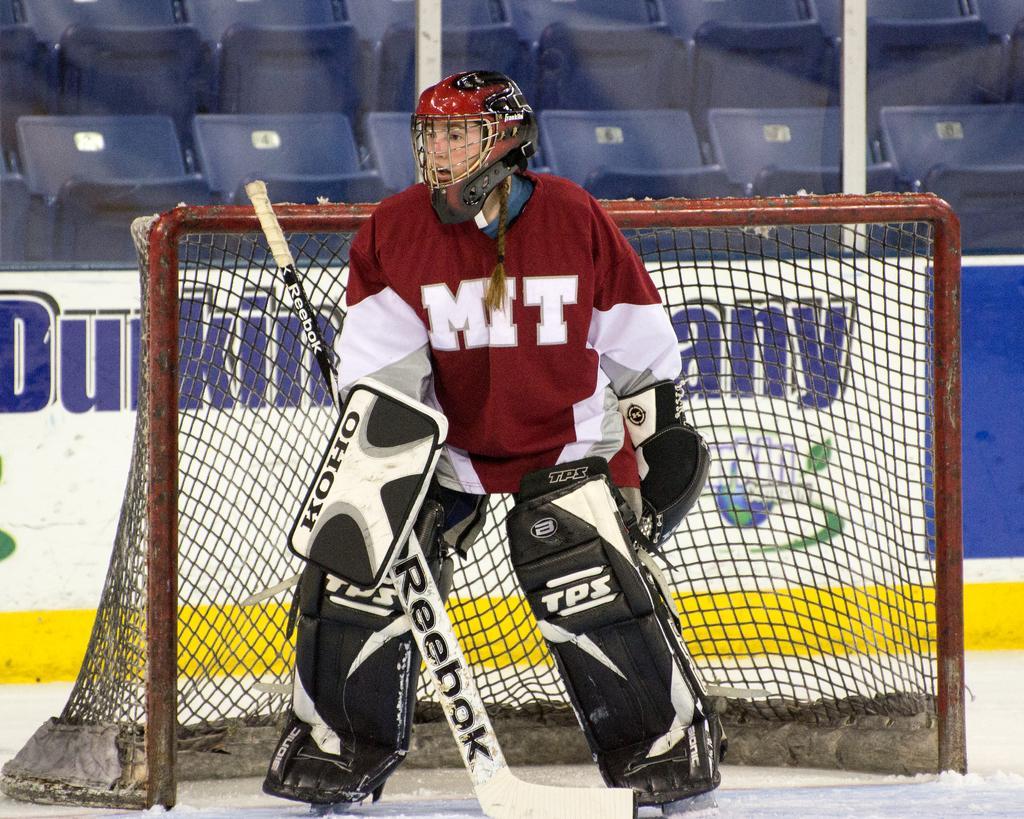Please provide a concise description of this image. In this image we can see a man wearing the helmet and also holding an object. We can also see the fence, wall with the text and also the seats and rods and at the bottom we can see the snow. 